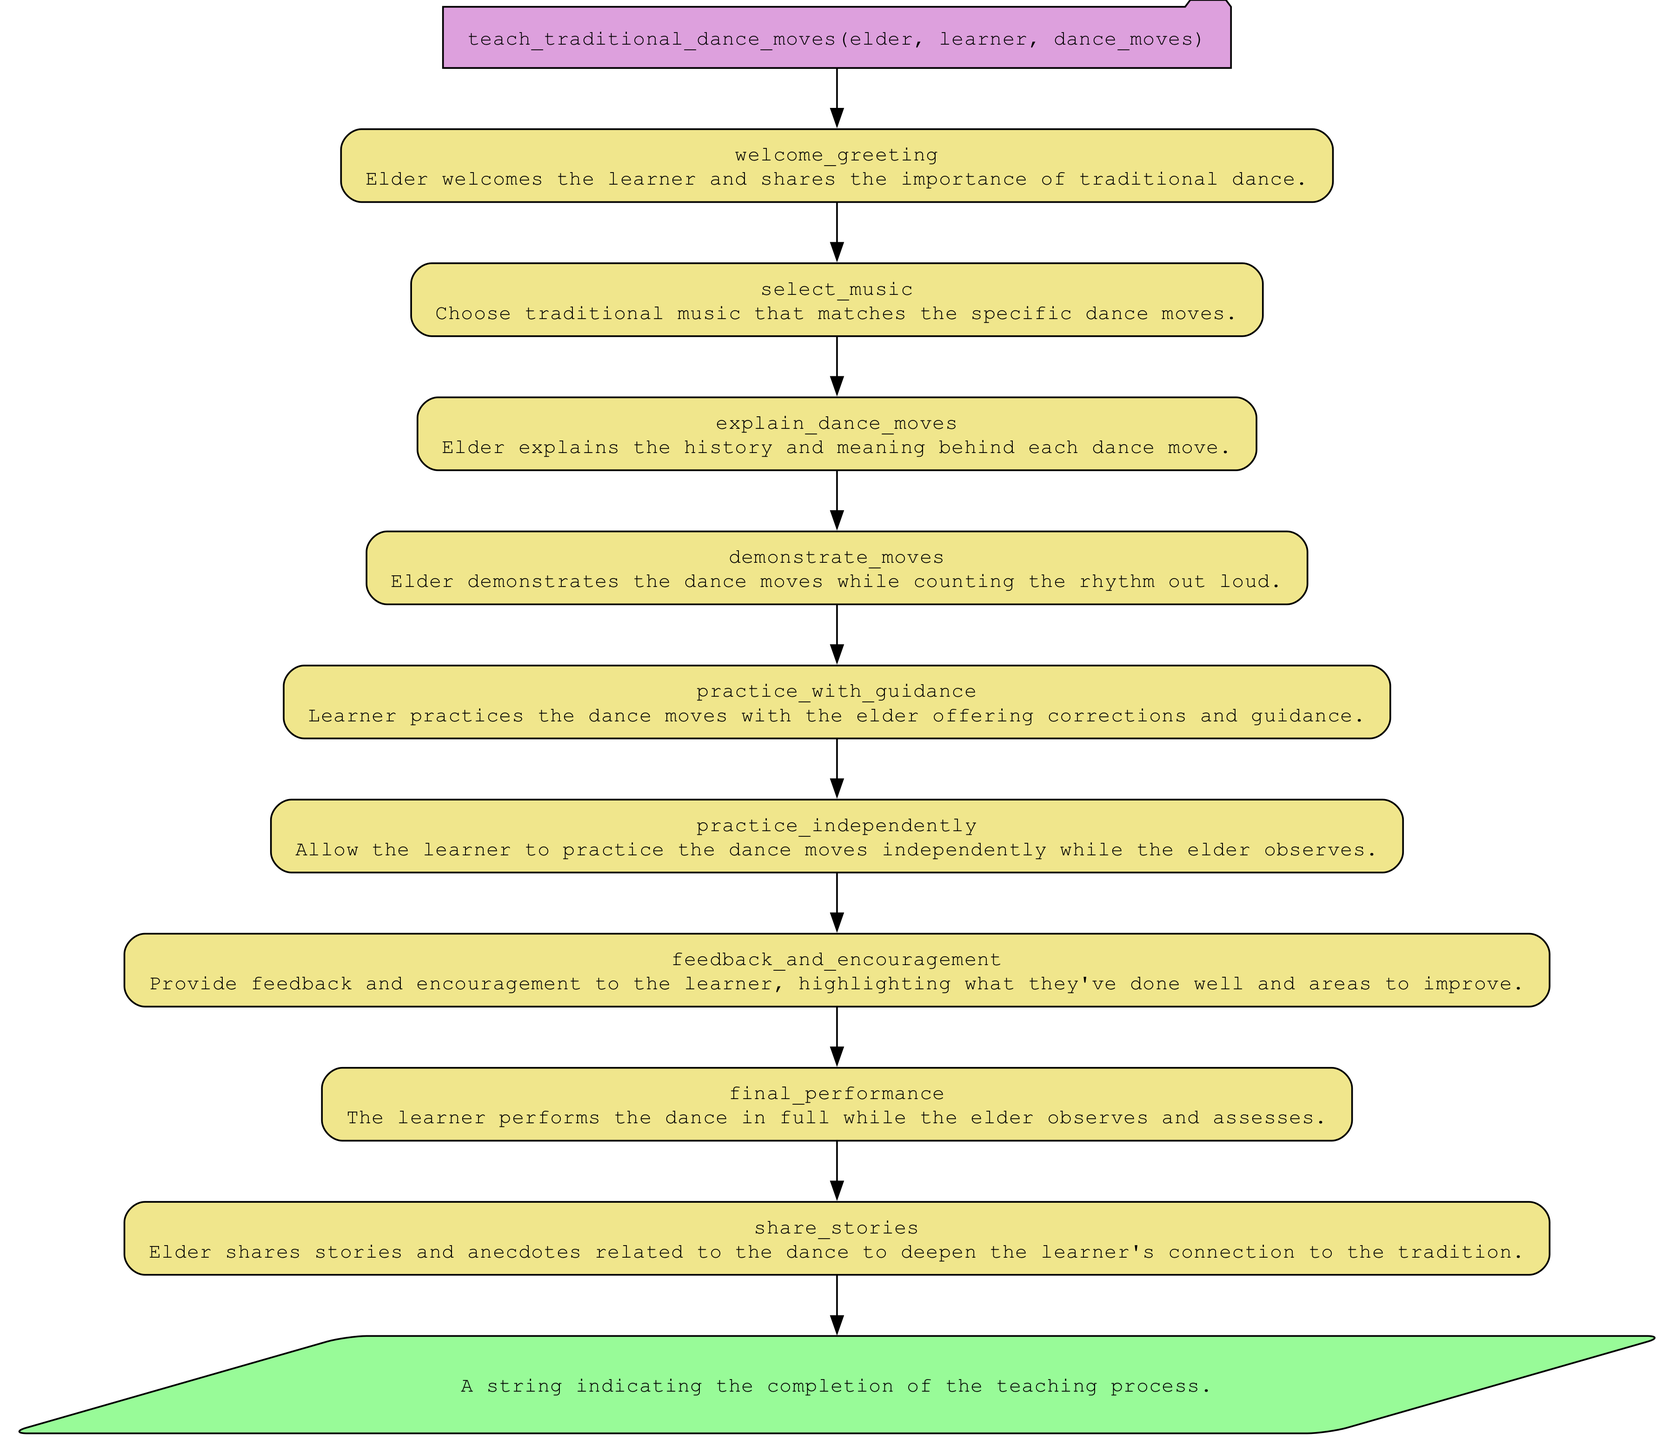What is the first step in the teaching process? The first step listed in the flowchart under the function "teach_traditional_dance_moves" is "welcome_greeting." It is the initial action taken after the function is called, establishing the teaching context.
Answer: welcome greeting How many steps are there in the teaching process? The diagram outlines a total of nine distinct steps in the teaching process from "welcome_greeting" to "share_stories." Each step is represented as a separate node in the flowchart.
Answer: nine Which step follows "demonstrate_moves"? Following the node "demonstrate_moves," the next step as indicated in the flowchart is "practice_with_guidance." This shows the sequence of actions taken in the teaching process after the demonstration.
Answer: practice with guidance What type of node is used to indicate the return value? The return value in the flowchart is indicated by a parallelogram node, which is a standard representation for output in flowcharts. This specific shape suggests it conveys the end result of the function's execution.
Answer: parallelogram What does the elder provide after the learner practices independently? After the learner has practiced independently, the elder provides "feedback_and_encouragement." This step emphasizes the importance of constructive criticism and support following independent practice.
Answer: feedback and encouragement How does the flowchart show the relationship between the "select_music" and "explain_dance_moves" steps? The flowchart illustrates that "select_music" directly leads to "explain_dance_moves," indicating a sequential relationship where one step must occur before the next in the teaching process.
Answer: direct connection What is indicated by the final node in the flowchart? The final node, labeled with the return value, signifies the completion of the teaching process. It encapsulates the end result of the function after all the teaching steps have been carried out.
Answer: completion of the teaching process Which node includes the importance of traditional dance? The node "welcome_greeting" includes a description that references the importance of traditional dance, providing context for the entire teaching process. This step sets the tone for learning the dance moves.
Answer: welcome greeting What does the elder demonstrate during the dance teaching process? The elder demonstrates the dance moves while counting the rhythm out loud, providing both visual and auditory guidance to the learner during this essential step.
Answer: dance moves 